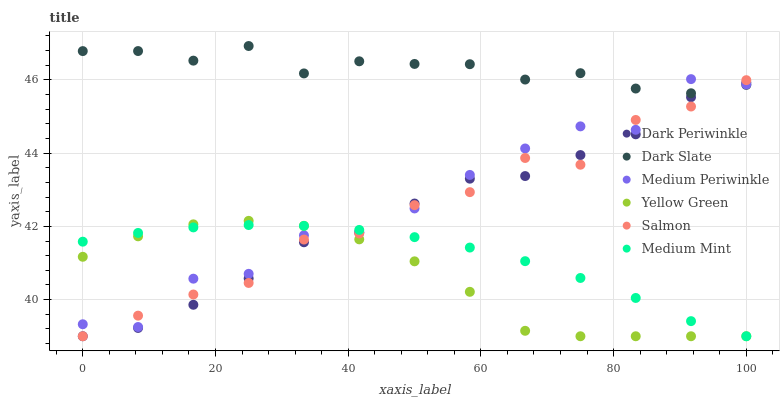Does Yellow Green have the minimum area under the curve?
Answer yes or no. Yes. Does Dark Slate have the maximum area under the curve?
Answer yes or no. Yes. Does Medium Periwinkle have the minimum area under the curve?
Answer yes or no. No. Does Medium Periwinkle have the maximum area under the curve?
Answer yes or no. No. Is Medium Mint the smoothest?
Answer yes or no. Yes. Is Medium Periwinkle the roughest?
Answer yes or no. Yes. Is Yellow Green the smoothest?
Answer yes or no. No. Is Yellow Green the roughest?
Answer yes or no. No. Does Medium Mint have the lowest value?
Answer yes or no. Yes. Does Medium Periwinkle have the lowest value?
Answer yes or no. No. Does Dark Slate have the highest value?
Answer yes or no. Yes. Does Yellow Green have the highest value?
Answer yes or no. No. Is Medium Mint less than Dark Slate?
Answer yes or no. Yes. Is Dark Slate greater than Medium Mint?
Answer yes or no. Yes. Does Salmon intersect Dark Slate?
Answer yes or no. Yes. Is Salmon less than Dark Slate?
Answer yes or no. No. Is Salmon greater than Dark Slate?
Answer yes or no. No. Does Medium Mint intersect Dark Slate?
Answer yes or no. No. 